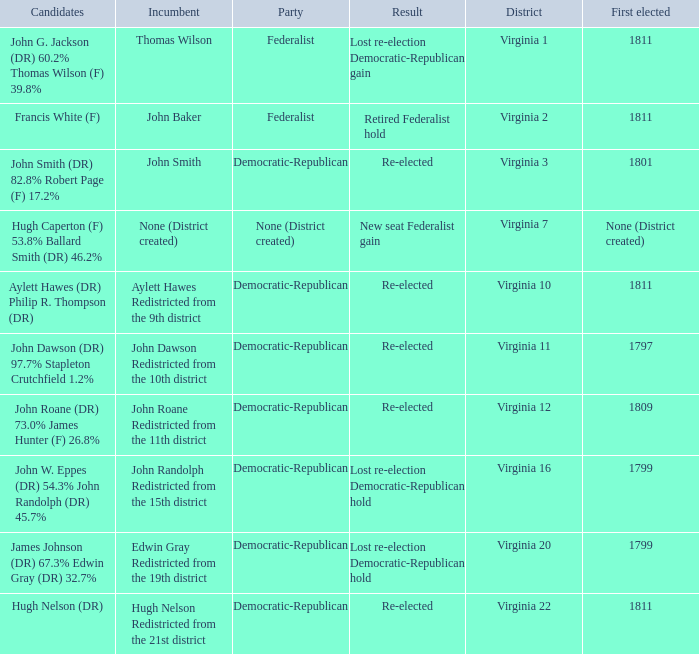Name the distrct for thomas wilson Virginia 1. 